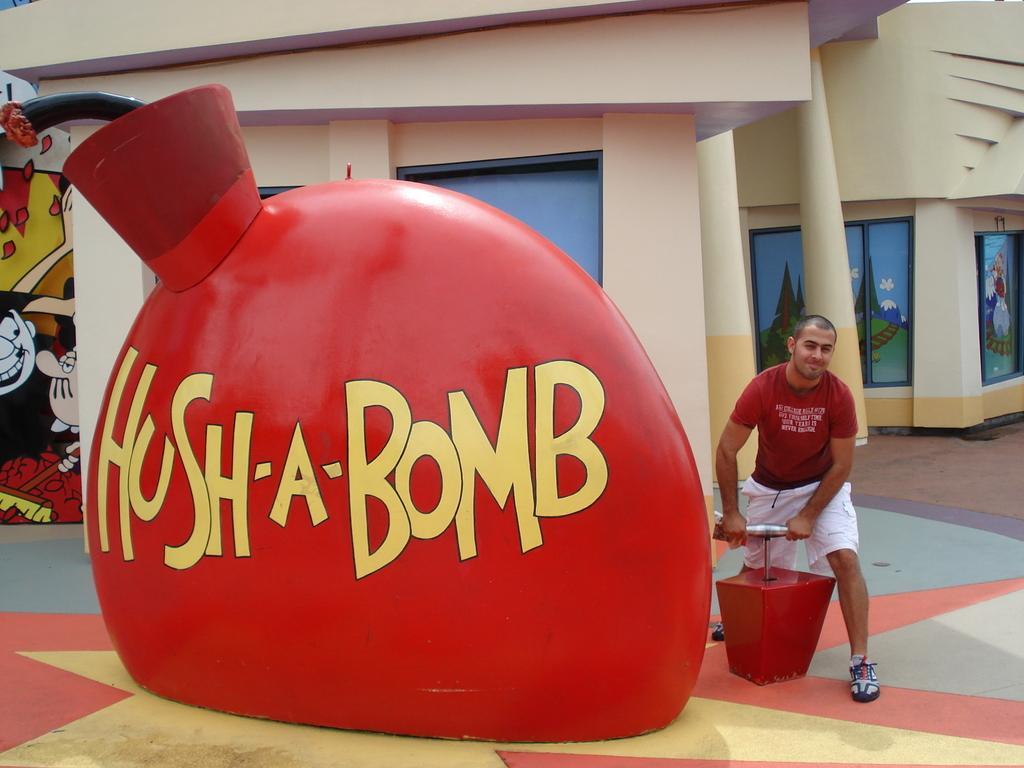Could you give a brief overview of what you see in this image? In this picture I can see a red color thing in front on which there are words written and side to it I can see a man who is holding a thing which is of silver and red color. In the background I can see the buildings and on the walls I can see the art of cartoon pictures. 